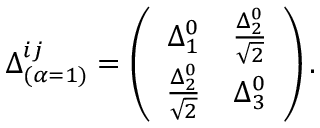Convert formula to latex. <formula><loc_0><loc_0><loc_500><loc_500>\Delta _ { ( \alpha = 1 ) } ^ { i j } = \left ( \begin{array} { c c } { { \Delta _ { 1 } ^ { 0 } } } & { { \frac { \Delta _ { 2 } ^ { 0 } } { \sqrt { 2 } } } } \\ { { \frac { \Delta _ { 2 } ^ { 0 } } { \sqrt { 2 } } } } & { { \Delta _ { 3 } ^ { 0 } } } \end{array} \right ) .</formula> 